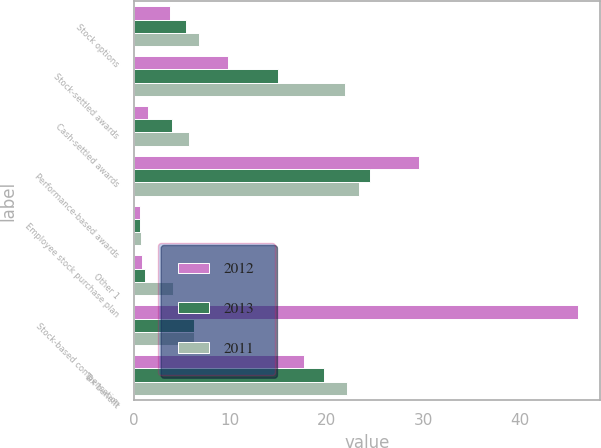<chart> <loc_0><loc_0><loc_500><loc_500><stacked_bar_chart><ecel><fcel>Stock options<fcel>Stock-settled awards<fcel>Cash-settled awards<fcel>Performance-based awards<fcel>Employee stock purchase plan<fcel>Other 1<fcel>Stock-based compensation<fcel>Tax benefit<nl><fcel>2012<fcel>3.7<fcel>9.8<fcel>1.5<fcel>29.6<fcel>0.6<fcel>0.8<fcel>46<fcel>17.6<nl><fcel>2013<fcel>5.4<fcel>14.9<fcel>3.9<fcel>24.5<fcel>0.6<fcel>1.1<fcel>6.2<fcel>19.7<nl><fcel>2011<fcel>6.7<fcel>21.9<fcel>5.7<fcel>23.3<fcel>0.7<fcel>4.1<fcel>6.2<fcel>22.1<nl></chart> 